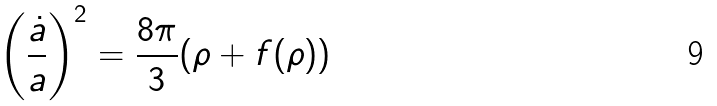Convert formula to latex. <formula><loc_0><loc_0><loc_500><loc_500>\left ( \frac { \dot { a } } { a } \right ) ^ { 2 } = \frac { 8 \pi } 3 ( \rho + f ( \rho ) )</formula> 